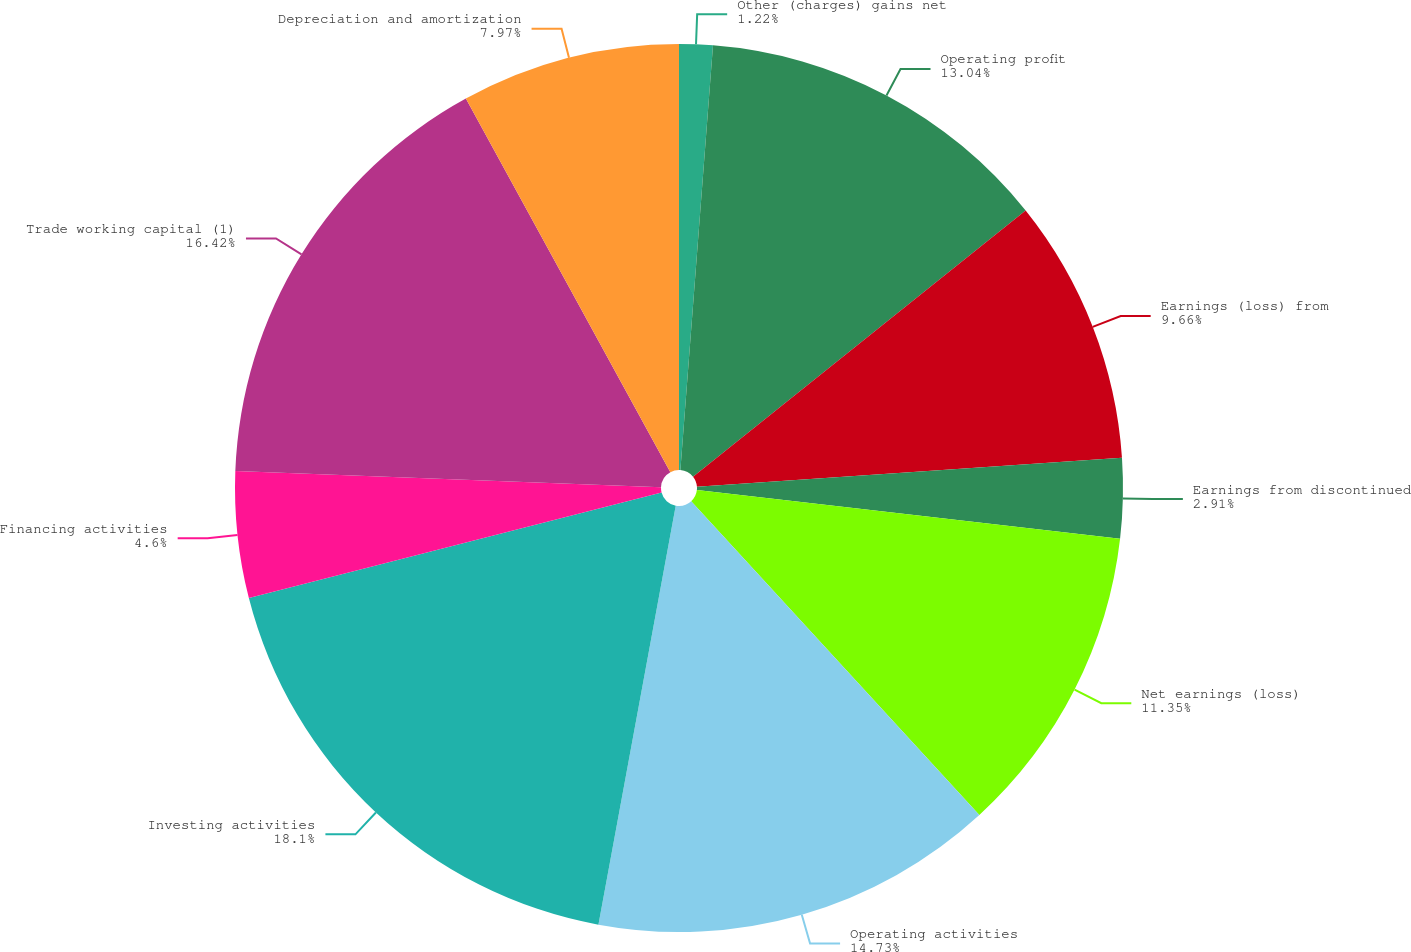<chart> <loc_0><loc_0><loc_500><loc_500><pie_chart><fcel>Other (charges) gains net<fcel>Operating profit<fcel>Earnings (loss) from<fcel>Earnings from discontinued<fcel>Net earnings (loss)<fcel>Operating activities<fcel>Investing activities<fcel>Financing activities<fcel>Trade working capital (1)<fcel>Depreciation and amortization<nl><fcel>1.22%<fcel>13.04%<fcel>9.66%<fcel>2.91%<fcel>11.35%<fcel>14.73%<fcel>18.11%<fcel>4.6%<fcel>16.42%<fcel>7.97%<nl></chart> 